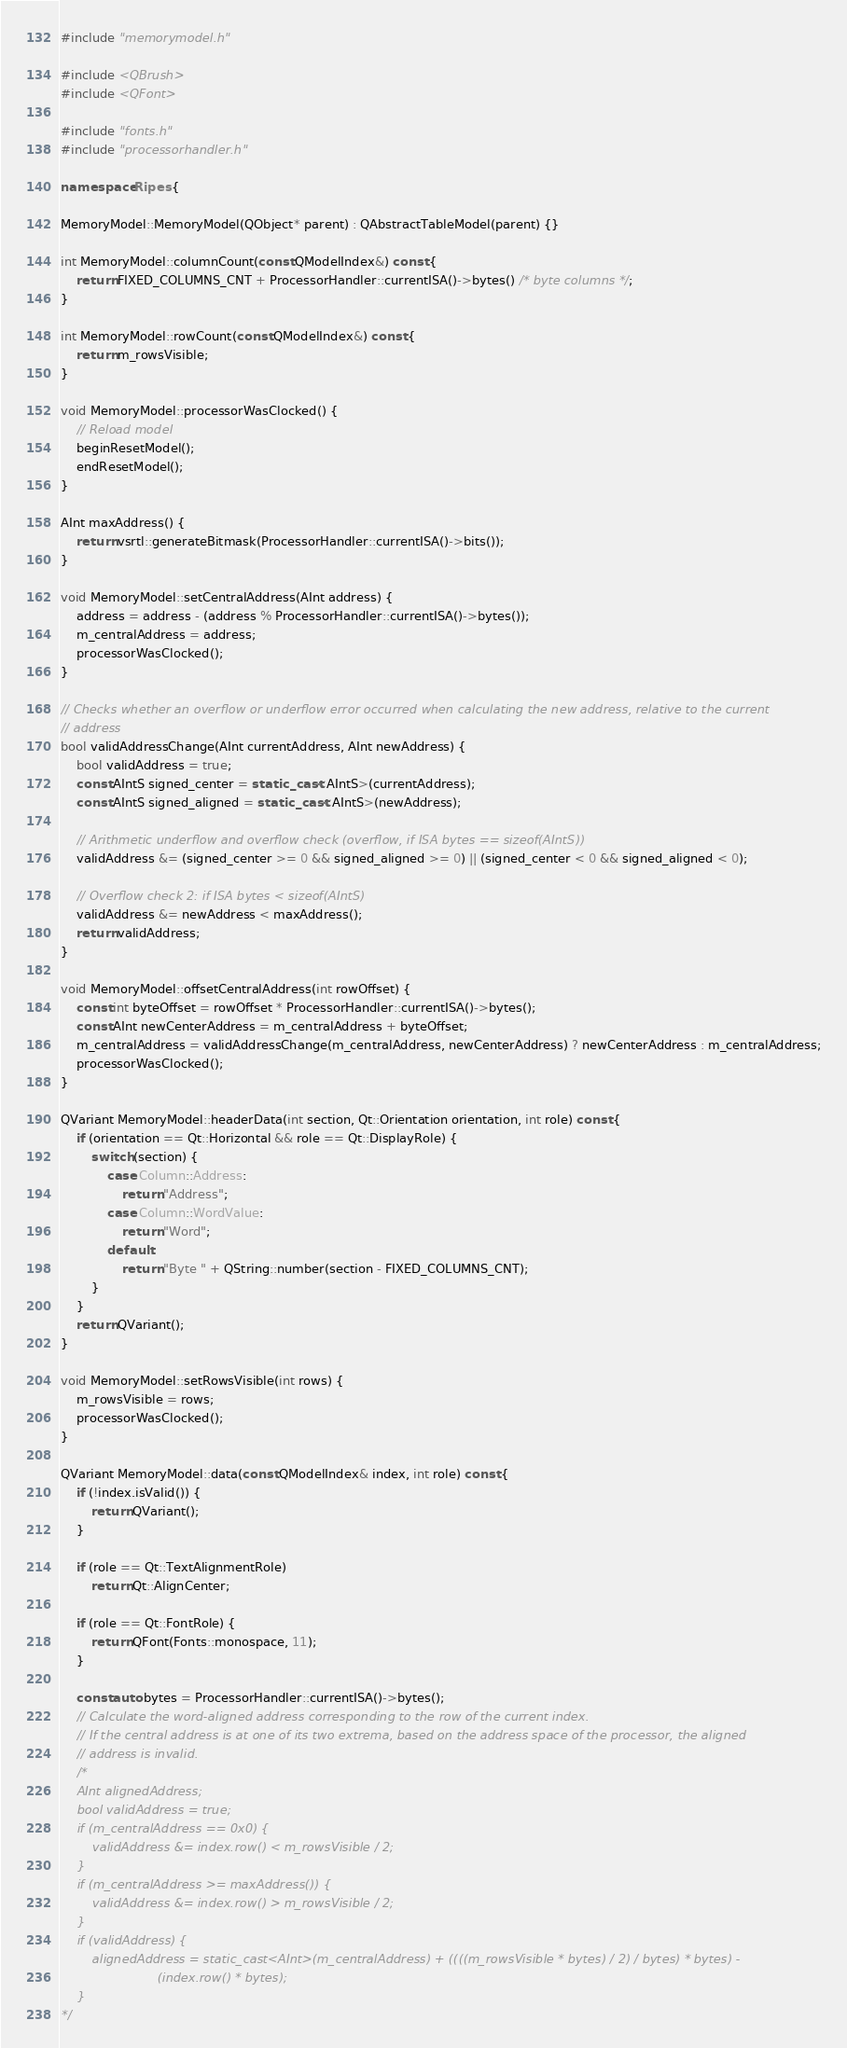<code> <loc_0><loc_0><loc_500><loc_500><_C++_>#include "memorymodel.h"

#include <QBrush>
#include <QFont>

#include "fonts.h"
#include "processorhandler.h"

namespace Ripes {

MemoryModel::MemoryModel(QObject* parent) : QAbstractTableModel(parent) {}

int MemoryModel::columnCount(const QModelIndex&) const {
    return FIXED_COLUMNS_CNT + ProcessorHandler::currentISA()->bytes() /* byte columns */;
}

int MemoryModel::rowCount(const QModelIndex&) const {
    return m_rowsVisible;
}

void MemoryModel::processorWasClocked() {
    // Reload model
    beginResetModel();
    endResetModel();
}

AInt maxAddress() {
    return vsrtl::generateBitmask(ProcessorHandler::currentISA()->bits());
}

void MemoryModel::setCentralAddress(AInt address) {
    address = address - (address % ProcessorHandler::currentISA()->bytes());
    m_centralAddress = address;
    processorWasClocked();
}

// Checks whether an overflow or underflow error occurred when calculating the new address, relative to the current
// address
bool validAddressChange(AInt currentAddress, AInt newAddress) {
    bool validAddress = true;
    const AIntS signed_center = static_cast<AIntS>(currentAddress);
    const AIntS signed_aligned = static_cast<AIntS>(newAddress);

    // Arithmetic underflow and overflow check (overflow, if ISA bytes == sizeof(AIntS))
    validAddress &= (signed_center >= 0 && signed_aligned >= 0) || (signed_center < 0 && signed_aligned < 0);

    // Overflow check 2: if ISA bytes < sizeof(AIntS)
    validAddress &= newAddress < maxAddress();
    return validAddress;
}

void MemoryModel::offsetCentralAddress(int rowOffset) {
    const int byteOffset = rowOffset * ProcessorHandler::currentISA()->bytes();
    const AInt newCenterAddress = m_centralAddress + byteOffset;
    m_centralAddress = validAddressChange(m_centralAddress, newCenterAddress) ? newCenterAddress : m_centralAddress;
    processorWasClocked();
}

QVariant MemoryModel::headerData(int section, Qt::Orientation orientation, int role) const {
    if (orientation == Qt::Horizontal && role == Qt::DisplayRole) {
        switch (section) {
            case Column::Address:
                return "Address";
            case Column::WordValue:
                return "Word";
            default:
                return "Byte " + QString::number(section - FIXED_COLUMNS_CNT);
        }
    }
    return QVariant();
}

void MemoryModel::setRowsVisible(int rows) {
    m_rowsVisible = rows;
    processorWasClocked();
}

QVariant MemoryModel::data(const QModelIndex& index, int role) const {
    if (!index.isValid()) {
        return QVariant();
    }

    if (role == Qt::TextAlignmentRole)
        return Qt::AlignCenter;

    if (role == Qt::FontRole) {
        return QFont(Fonts::monospace, 11);
    }

    const auto bytes = ProcessorHandler::currentISA()->bytes();
    // Calculate the word-aligned address corresponding to the row of the current index.
    // If the central address is at one of its two extrema, based on the address space of the processor, the aligned
    // address is invalid.
    /*
    AInt alignedAddress;
    bool validAddress = true;
    if (m_centralAddress == 0x0) {
        validAddress &= index.row() < m_rowsVisible / 2;
    }
    if (m_centralAddress >= maxAddress()) {
        validAddress &= index.row() > m_rowsVisible / 2;
    }
    if (validAddress) {
        alignedAddress = static_cast<AInt>(m_centralAddress) + ((((m_rowsVisible * bytes) / 2) / bytes) * bytes) -
                         (index.row() * bytes);
    }
*/
</code> 